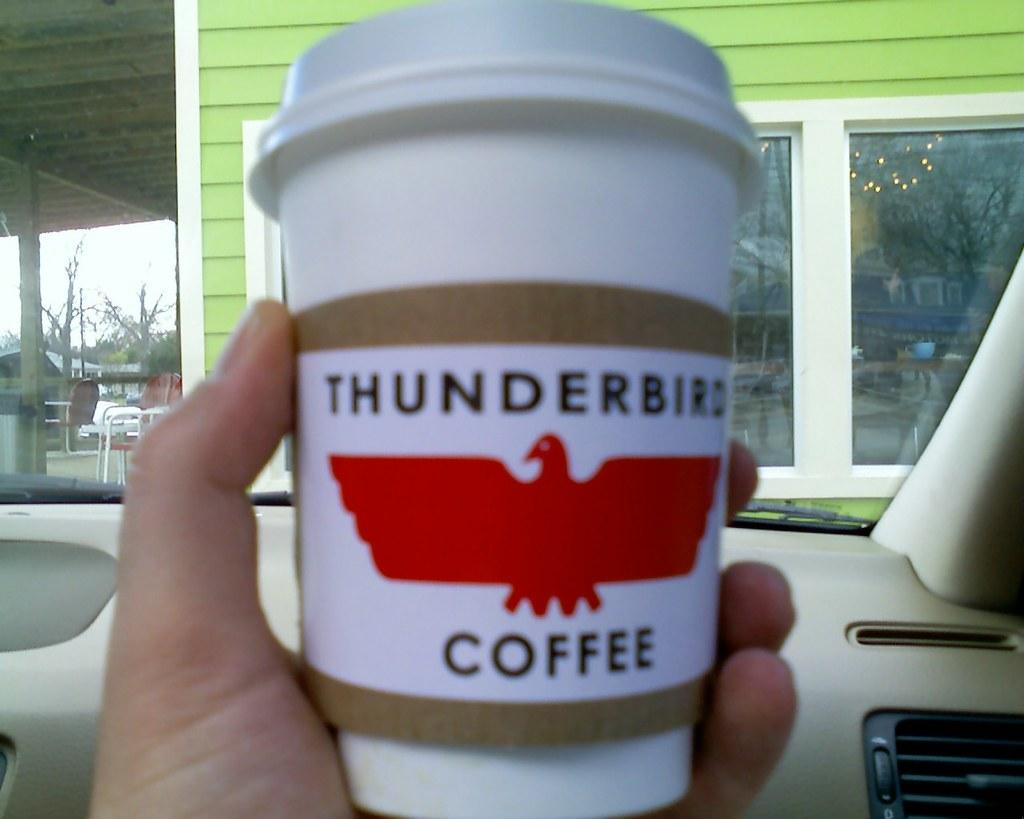What is the main object in the image? There is a coffee cup in the image. Who is holding the coffee cup? The coffee cup is being held by someone. What type of leaf is being used as a team mascot in the image? There is no leaf or team mascot present in the image; it only features a coffee cup being held by someone. 